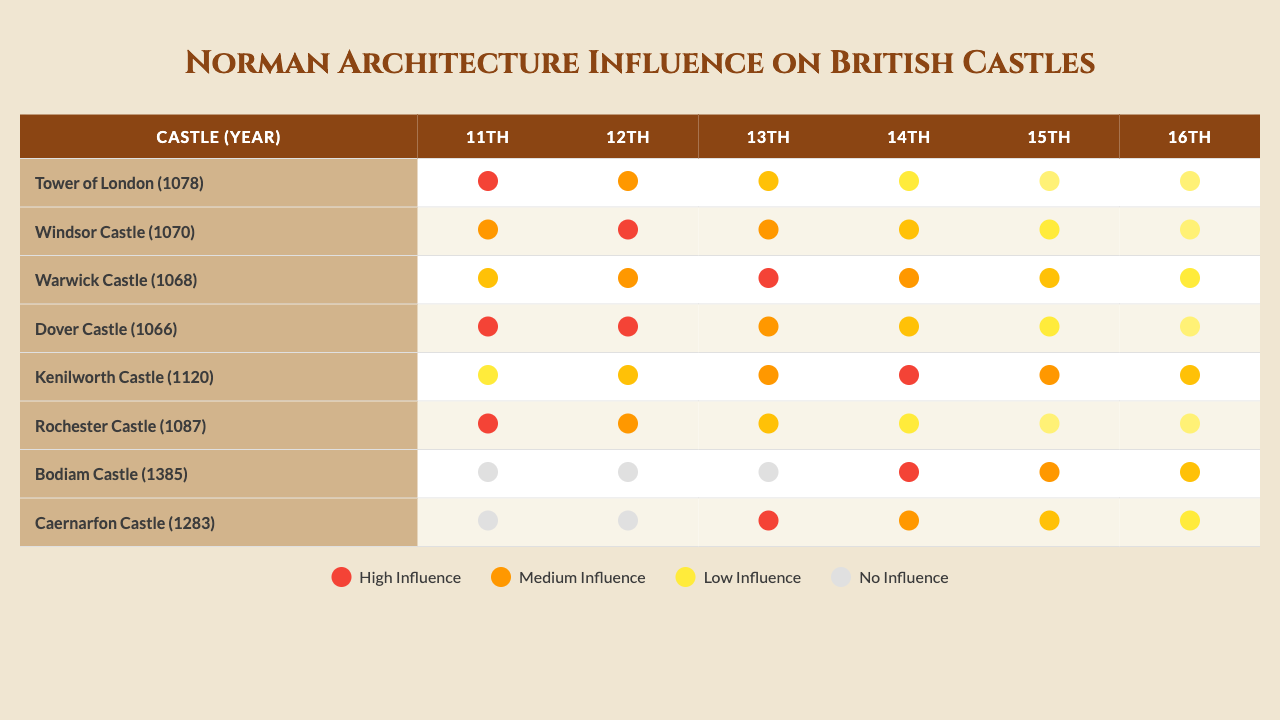What is the highest influence score for the 11th century among the listed castles? The table reveals the influence scores for each castle in the 11th century. The scores are: Tower of London (5), Windsor Castle (4), Warwick Castle (3), Dover Castle (5), Rochester Castle (5). The highest score is 5.
Answer: 5 Which castle has the earliest construction year? By reviewing the construction years listed for each castle, the earliest year found is 1066 for Dover Castle.
Answer: Dover Castle What is the average norman influence score for the 12th century? The scores for the 12th century are: Windsor Castle (5), Warwick Castle (4), Kenilworth Castle (3), Rochester Castle (4). We add these up: (5 + 4 + 3 + 4 = 16) and divide by the number of castles (4) to get 16/4 = 4.
Answer: 4 Is Bodiam Castle the only castle in the 14th century that shows Norman influence? Looking at the table, Bodiam Castle shows an influence score of 5 in the 14th century, while no other castles are listed for this century. Thus, it is the only one present.
Answer: Yes What trend can be observed in the norman influence scores from the 11th to the 15th century? Analyzing the norman influence scores across these centuries, there is a general decline over time, particularly after the 12th century, where many scores drop significantly, indicating less incorporation of Norman features in later castles.
Answer: Decline Which castle in the 13th century has the highest norman influence score? The scores for the 13th century are: Warwick Castle (5), Kenilworth Castle (4), Caernarfon Castle (5). Both Warwick Castle and Caernarfon Castle tie for the highest score of 5.
Answer: Warwick Castle and Caernarfon Castle What is the total number of castles that exhibit no influence in the 11th century? The only castle that has a score of 0 for the 11th century is Bodiam Castle, while all others have positive scores. Therefore, the total count is one.
Answer: 1 Which century had the highest average norman influence score across all the castles presented? Calculating averages, from the table: 11th (3.67), 12th (4), 13th (3.79), 14th (2.50), 15th (2.00). The highest average is for the 12th century with 4.
Answer: 12th century What percentage of the castles were constructed prior to the year 1100? There are 7 castles presented, and counting those constructed before 1100, we find: Dover Castle, Warwick Castle, Windsor Castle, and Tower of London (4). Therefore, the percentage is (4/7)*100 = approximately 57.14%.
Answer: Approximately 57.14% Which castle had the least influence score in the 15th century? The influence scores for the 15th century are: Bodiam Castle (4), Caernarfon Castle (3). Therefore, the least score is 2 belonging to Castle Caernarfon.
Answer: Caernarfon Castle 